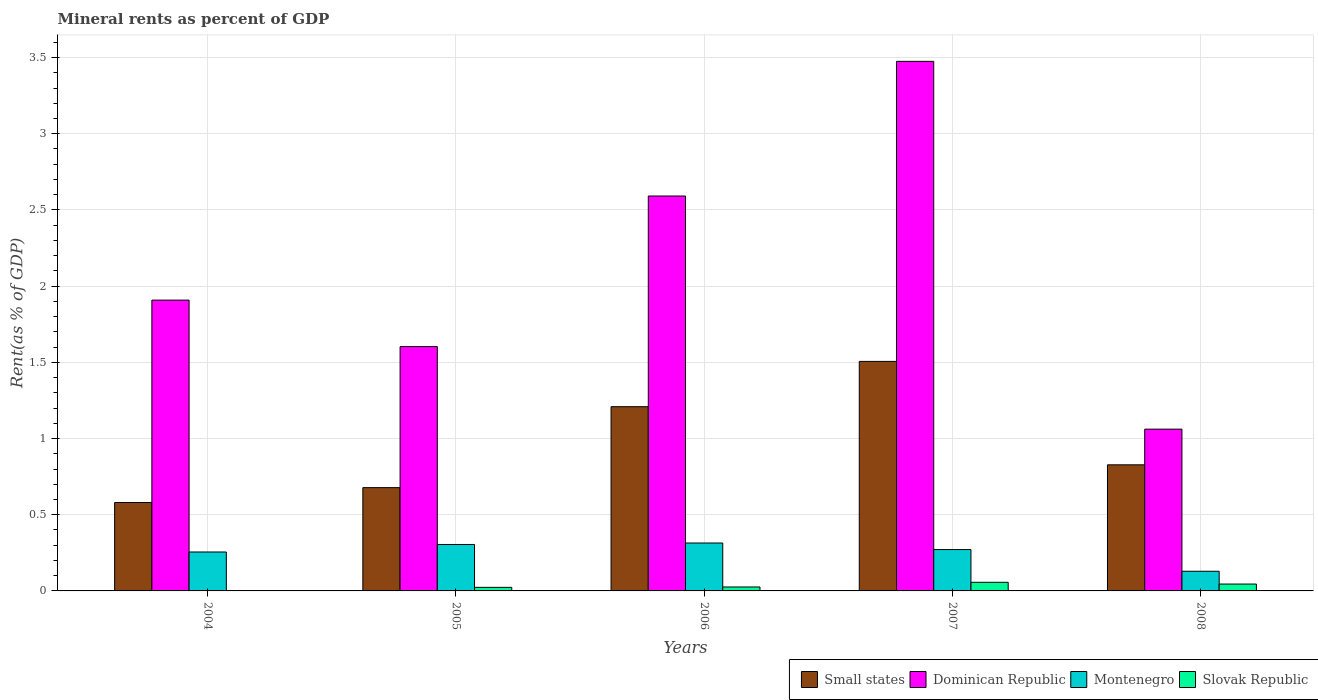How many bars are there on the 3rd tick from the left?
Make the answer very short. 4. What is the label of the 1st group of bars from the left?
Your answer should be very brief. 2004. What is the mineral rent in Montenegro in 2007?
Make the answer very short. 0.27. Across all years, what is the maximum mineral rent in Montenegro?
Ensure brevity in your answer.  0.31. Across all years, what is the minimum mineral rent in Montenegro?
Your response must be concise. 0.13. What is the total mineral rent in Slovak Republic in the graph?
Offer a very short reply. 0.15. What is the difference between the mineral rent in Dominican Republic in 2007 and that in 2008?
Keep it short and to the point. 2.41. What is the difference between the mineral rent in Small states in 2008 and the mineral rent in Montenegro in 2004?
Give a very brief answer. 0.57. What is the average mineral rent in Montenegro per year?
Your response must be concise. 0.26. In the year 2005, what is the difference between the mineral rent in Dominican Republic and mineral rent in Montenegro?
Provide a short and direct response. 1.3. What is the ratio of the mineral rent in Dominican Republic in 2007 to that in 2008?
Offer a very short reply. 3.27. Is the mineral rent in Dominican Republic in 2004 less than that in 2006?
Give a very brief answer. Yes. Is the difference between the mineral rent in Dominican Republic in 2005 and 2006 greater than the difference between the mineral rent in Montenegro in 2005 and 2006?
Your answer should be compact. No. What is the difference between the highest and the second highest mineral rent in Slovak Republic?
Give a very brief answer. 0.01. What is the difference between the highest and the lowest mineral rent in Montenegro?
Keep it short and to the point. 0.19. In how many years, is the mineral rent in Montenegro greater than the average mineral rent in Montenegro taken over all years?
Give a very brief answer. 4. What does the 2nd bar from the left in 2006 represents?
Provide a short and direct response. Dominican Republic. What does the 1st bar from the right in 2007 represents?
Make the answer very short. Slovak Republic. Is it the case that in every year, the sum of the mineral rent in Slovak Republic and mineral rent in Small states is greater than the mineral rent in Dominican Republic?
Offer a terse response. No. How many bars are there?
Offer a terse response. 20. Are all the bars in the graph horizontal?
Your answer should be compact. No. Where does the legend appear in the graph?
Your answer should be very brief. Bottom right. What is the title of the graph?
Ensure brevity in your answer.  Mineral rents as percent of GDP. Does "Turkmenistan" appear as one of the legend labels in the graph?
Make the answer very short. No. What is the label or title of the Y-axis?
Keep it short and to the point. Rent(as % of GDP). What is the Rent(as % of GDP) of Small states in 2004?
Make the answer very short. 0.58. What is the Rent(as % of GDP) of Dominican Republic in 2004?
Make the answer very short. 1.91. What is the Rent(as % of GDP) in Montenegro in 2004?
Keep it short and to the point. 0.26. What is the Rent(as % of GDP) of Slovak Republic in 2004?
Your answer should be very brief. 0. What is the Rent(as % of GDP) in Small states in 2005?
Provide a short and direct response. 0.68. What is the Rent(as % of GDP) in Dominican Republic in 2005?
Give a very brief answer. 1.6. What is the Rent(as % of GDP) in Montenegro in 2005?
Your response must be concise. 0.3. What is the Rent(as % of GDP) of Slovak Republic in 2005?
Ensure brevity in your answer.  0.02. What is the Rent(as % of GDP) in Small states in 2006?
Keep it short and to the point. 1.21. What is the Rent(as % of GDP) in Dominican Republic in 2006?
Your response must be concise. 2.59. What is the Rent(as % of GDP) in Montenegro in 2006?
Provide a succinct answer. 0.31. What is the Rent(as % of GDP) in Slovak Republic in 2006?
Provide a succinct answer. 0.03. What is the Rent(as % of GDP) in Small states in 2007?
Give a very brief answer. 1.51. What is the Rent(as % of GDP) in Dominican Republic in 2007?
Make the answer very short. 3.47. What is the Rent(as % of GDP) in Montenegro in 2007?
Your answer should be very brief. 0.27. What is the Rent(as % of GDP) of Slovak Republic in 2007?
Make the answer very short. 0.06. What is the Rent(as % of GDP) of Small states in 2008?
Keep it short and to the point. 0.83. What is the Rent(as % of GDP) in Dominican Republic in 2008?
Keep it short and to the point. 1.06. What is the Rent(as % of GDP) of Montenegro in 2008?
Provide a short and direct response. 0.13. What is the Rent(as % of GDP) in Slovak Republic in 2008?
Your answer should be very brief. 0.05. Across all years, what is the maximum Rent(as % of GDP) in Small states?
Provide a short and direct response. 1.51. Across all years, what is the maximum Rent(as % of GDP) of Dominican Republic?
Make the answer very short. 3.47. Across all years, what is the maximum Rent(as % of GDP) of Montenegro?
Give a very brief answer. 0.31. Across all years, what is the maximum Rent(as % of GDP) of Slovak Republic?
Your answer should be compact. 0.06. Across all years, what is the minimum Rent(as % of GDP) of Small states?
Your answer should be compact. 0.58. Across all years, what is the minimum Rent(as % of GDP) of Dominican Republic?
Your answer should be very brief. 1.06. Across all years, what is the minimum Rent(as % of GDP) of Montenegro?
Make the answer very short. 0.13. Across all years, what is the minimum Rent(as % of GDP) in Slovak Republic?
Offer a very short reply. 0. What is the total Rent(as % of GDP) in Small states in the graph?
Provide a succinct answer. 4.8. What is the total Rent(as % of GDP) of Dominican Republic in the graph?
Provide a short and direct response. 10.64. What is the total Rent(as % of GDP) in Montenegro in the graph?
Make the answer very short. 1.28. What is the total Rent(as % of GDP) in Slovak Republic in the graph?
Provide a short and direct response. 0.15. What is the difference between the Rent(as % of GDP) in Small states in 2004 and that in 2005?
Offer a terse response. -0.1. What is the difference between the Rent(as % of GDP) in Dominican Republic in 2004 and that in 2005?
Provide a succinct answer. 0.3. What is the difference between the Rent(as % of GDP) in Montenegro in 2004 and that in 2005?
Provide a short and direct response. -0.05. What is the difference between the Rent(as % of GDP) of Slovak Republic in 2004 and that in 2005?
Your response must be concise. -0.02. What is the difference between the Rent(as % of GDP) of Small states in 2004 and that in 2006?
Provide a short and direct response. -0.63. What is the difference between the Rent(as % of GDP) in Dominican Republic in 2004 and that in 2006?
Your response must be concise. -0.68. What is the difference between the Rent(as % of GDP) in Montenegro in 2004 and that in 2006?
Ensure brevity in your answer.  -0.06. What is the difference between the Rent(as % of GDP) in Slovak Republic in 2004 and that in 2006?
Your answer should be compact. -0.02. What is the difference between the Rent(as % of GDP) of Small states in 2004 and that in 2007?
Ensure brevity in your answer.  -0.93. What is the difference between the Rent(as % of GDP) of Dominican Republic in 2004 and that in 2007?
Offer a very short reply. -1.57. What is the difference between the Rent(as % of GDP) in Montenegro in 2004 and that in 2007?
Your response must be concise. -0.02. What is the difference between the Rent(as % of GDP) in Slovak Republic in 2004 and that in 2007?
Offer a terse response. -0.06. What is the difference between the Rent(as % of GDP) of Small states in 2004 and that in 2008?
Your response must be concise. -0.25. What is the difference between the Rent(as % of GDP) of Dominican Republic in 2004 and that in 2008?
Your response must be concise. 0.85. What is the difference between the Rent(as % of GDP) in Montenegro in 2004 and that in 2008?
Ensure brevity in your answer.  0.13. What is the difference between the Rent(as % of GDP) in Slovak Republic in 2004 and that in 2008?
Make the answer very short. -0.04. What is the difference between the Rent(as % of GDP) of Small states in 2005 and that in 2006?
Provide a short and direct response. -0.53. What is the difference between the Rent(as % of GDP) of Dominican Republic in 2005 and that in 2006?
Offer a very short reply. -0.99. What is the difference between the Rent(as % of GDP) in Montenegro in 2005 and that in 2006?
Offer a very short reply. -0.01. What is the difference between the Rent(as % of GDP) in Slovak Republic in 2005 and that in 2006?
Offer a very short reply. -0. What is the difference between the Rent(as % of GDP) in Small states in 2005 and that in 2007?
Your answer should be compact. -0.83. What is the difference between the Rent(as % of GDP) in Dominican Republic in 2005 and that in 2007?
Your response must be concise. -1.87. What is the difference between the Rent(as % of GDP) in Slovak Republic in 2005 and that in 2007?
Your answer should be compact. -0.03. What is the difference between the Rent(as % of GDP) in Small states in 2005 and that in 2008?
Offer a very short reply. -0.15. What is the difference between the Rent(as % of GDP) in Dominican Republic in 2005 and that in 2008?
Offer a terse response. 0.54. What is the difference between the Rent(as % of GDP) of Montenegro in 2005 and that in 2008?
Provide a succinct answer. 0.18. What is the difference between the Rent(as % of GDP) of Slovak Republic in 2005 and that in 2008?
Offer a terse response. -0.02. What is the difference between the Rent(as % of GDP) in Small states in 2006 and that in 2007?
Provide a succinct answer. -0.3. What is the difference between the Rent(as % of GDP) in Dominican Republic in 2006 and that in 2007?
Give a very brief answer. -0.88. What is the difference between the Rent(as % of GDP) of Montenegro in 2006 and that in 2007?
Your answer should be very brief. 0.04. What is the difference between the Rent(as % of GDP) of Slovak Republic in 2006 and that in 2007?
Your response must be concise. -0.03. What is the difference between the Rent(as % of GDP) in Small states in 2006 and that in 2008?
Make the answer very short. 0.38. What is the difference between the Rent(as % of GDP) of Dominican Republic in 2006 and that in 2008?
Ensure brevity in your answer.  1.53. What is the difference between the Rent(as % of GDP) in Montenegro in 2006 and that in 2008?
Offer a terse response. 0.19. What is the difference between the Rent(as % of GDP) of Slovak Republic in 2006 and that in 2008?
Make the answer very short. -0.02. What is the difference between the Rent(as % of GDP) of Small states in 2007 and that in 2008?
Your response must be concise. 0.68. What is the difference between the Rent(as % of GDP) in Dominican Republic in 2007 and that in 2008?
Keep it short and to the point. 2.41. What is the difference between the Rent(as % of GDP) of Montenegro in 2007 and that in 2008?
Give a very brief answer. 0.14. What is the difference between the Rent(as % of GDP) of Slovak Republic in 2007 and that in 2008?
Your response must be concise. 0.01. What is the difference between the Rent(as % of GDP) of Small states in 2004 and the Rent(as % of GDP) of Dominican Republic in 2005?
Offer a terse response. -1.02. What is the difference between the Rent(as % of GDP) of Small states in 2004 and the Rent(as % of GDP) of Montenegro in 2005?
Provide a short and direct response. 0.28. What is the difference between the Rent(as % of GDP) of Small states in 2004 and the Rent(as % of GDP) of Slovak Republic in 2005?
Provide a short and direct response. 0.56. What is the difference between the Rent(as % of GDP) of Dominican Republic in 2004 and the Rent(as % of GDP) of Montenegro in 2005?
Your answer should be compact. 1.6. What is the difference between the Rent(as % of GDP) in Dominican Republic in 2004 and the Rent(as % of GDP) in Slovak Republic in 2005?
Give a very brief answer. 1.88. What is the difference between the Rent(as % of GDP) of Montenegro in 2004 and the Rent(as % of GDP) of Slovak Republic in 2005?
Make the answer very short. 0.23. What is the difference between the Rent(as % of GDP) in Small states in 2004 and the Rent(as % of GDP) in Dominican Republic in 2006?
Provide a succinct answer. -2.01. What is the difference between the Rent(as % of GDP) in Small states in 2004 and the Rent(as % of GDP) in Montenegro in 2006?
Your response must be concise. 0.27. What is the difference between the Rent(as % of GDP) in Small states in 2004 and the Rent(as % of GDP) in Slovak Republic in 2006?
Your response must be concise. 0.55. What is the difference between the Rent(as % of GDP) in Dominican Republic in 2004 and the Rent(as % of GDP) in Montenegro in 2006?
Offer a very short reply. 1.59. What is the difference between the Rent(as % of GDP) of Dominican Republic in 2004 and the Rent(as % of GDP) of Slovak Republic in 2006?
Provide a short and direct response. 1.88. What is the difference between the Rent(as % of GDP) in Montenegro in 2004 and the Rent(as % of GDP) in Slovak Republic in 2006?
Your answer should be very brief. 0.23. What is the difference between the Rent(as % of GDP) in Small states in 2004 and the Rent(as % of GDP) in Dominican Republic in 2007?
Provide a succinct answer. -2.9. What is the difference between the Rent(as % of GDP) of Small states in 2004 and the Rent(as % of GDP) of Montenegro in 2007?
Give a very brief answer. 0.31. What is the difference between the Rent(as % of GDP) in Small states in 2004 and the Rent(as % of GDP) in Slovak Republic in 2007?
Make the answer very short. 0.52. What is the difference between the Rent(as % of GDP) in Dominican Republic in 2004 and the Rent(as % of GDP) in Montenegro in 2007?
Your answer should be compact. 1.64. What is the difference between the Rent(as % of GDP) of Dominican Republic in 2004 and the Rent(as % of GDP) of Slovak Republic in 2007?
Give a very brief answer. 1.85. What is the difference between the Rent(as % of GDP) in Montenegro in 2004 and the Rent(as % of GDP) in Slovak Republic in 2007?
Provide a short and direct response. 0.2. What is the difference between the Rent(as % of GDP) of Small states in 2004 and the Rent(as % of GDP) of Dominican Republic in 2008?
Provide a short and direct response. -0.48. What is the difference between the Rent(as % of GDP) in Small states in 2004 and the Rent(as % of GDP) in Montenegro in 2008?
Offer a very short reply. 0.45. What is the difference between the Rent(as % of GDP) in Small states in 2004 and the Rent(as % of GDP) in Slovak Republic in 2008?
Make the answer very short. 0.53. What is the difference between the Rent(as % of GDP) in Dominican Republic in 2004 and the Rent(as % of GDP) in Montenegro in 2008?
Provide a succinct answer. 1.78. What is the difference between the Rent(as % of GDP) of Dominican Republic in 2004 and the Rent(as % of GDP) of Slovak Republic in 2008?
Provide a short and direct response. 1.86. What is the difference between the Rent(as % of GDP) in Montenegro in 2004 and the Rent(as % of GDP) in Slovak Republic in 2008?
Offer a very short reply. 0.21. What is the difference between the Rent(as % of GDP) of Small states in 2005 and the Rent(as % of GDP) of Dominican Republic in 2006?
Give a very brief answer. -1.91. What is the difference between the Rent(as % of GDP) in Small states in 2005 and the Rent(as % of GDP) in Montenegro in 2006?
Keep it short and to the point. 0.36. What is the difference between the Rent(as % of GDP) in Small states in 2005 and the Rent(as % of GDP) in Slovak Republic in 2006?
Your answer should be very brief. 0.65. What is the difference between the Rent(as % of GDP) in Dominican Republic in 2005 and the Rent(as % of GDP) in Montenegro in 2006?
Make the answer very short. 1.29. What is the difference between the Rent(as % of GDP) of Dominican Republic in 2005 and the Rent(as % of GDP) of Slovak Republic in 2006?
Keep it short and to the point. 1.58. What is the difference between the Rent(as % of GDP) in Montenegro in 2005 and the Rent(as % of GDP) in Slovak Republic in 2006?
Ensure brevity in your answer.  0.28. What is the difference between the Rent(as % of GDP) of Small states in 2005 and the Rent(as % of GDP) of Dominican Republic in 2007?
Keep it short and to the point. -2.8. What is the difference between the Rent(as % of GDP) in Small states in 2005 and the Rent(as % of GDP) in Montenegro in 2007?
Make the answer very short. 0.41. What is the difference between the Rent(as % of GDP) of Small states in 2005 and the Rent(as % of GDP) of Slovak Republic in 2007?
Keep it short and to the point. 0.62. What is the difference between the Rent(as % of GDP) in Dominican Republic in 2005 and the Rent(as % of GDP) in Montenegro in 2007?
Make the answer very short. 1.33. What is the difference between the Rent(as % of GDP) in Dominican Republic in 2005 and the Rent(as % of GDP) in Slovak Republic in 2007?
Ensure brevity in your answer.  1.55. What is the difference between the Rent(as % of GDP) in Montenegro in 2005 and the Rent(as % of GDP) in Slovak Republic in 2007?
Give a very brief answer. 0.25. What is the difference between the Rent(as % of GDP) of Small states in 2005 and the Rent(as % of GDP) of Dominican Republic in 2008?
Ensure brevity in your answer.  -0.38. What is the difference between the Rent(as % of GDP) in Small states in 2005 and the Rent(as % of GDP) in Montenegro in 2008?
Make the answer very short. 0.55. What is the difference between the Rent(as % of GDP) in Small states in 2005 and the Rent(as % of GDP) in Slovak Republic in 2008?
Keep it short and to the point. 0.63. What is the difference between the Rent(as % of GDP) of Dominican Republic in 2005 and the Rent(as % of GDP) of Montenegro in 2008?
Offer a terse response. 1.47. What is the difference between the Rent(as % of GDP) in Dominican Republic in 2005 and the Rent(as % of GDP) in Slovak Republic in 2008?
Keep it short and to the point. 1.56. What is the difference between the Rent(as % of GDP) of Montenegro in 2005 and the Rent(as % of GDP) of Slovak Republic in 2008?
Provide a succinct answer. 0.26. What is the difference between the Rent(as % of GDP) of Small states in 2006 and the Rent(as % of GDP) of Dominican Republic in 2007?
Offer a terse response. -2.27. What is the difference between the Rent(as % of GDP) in Small states in 2006 and the Rent(as % of GDP) in Montenegro in 2007?
Keep it short and to the point. 0.94. What is the difference between the Rent(as % of GDP) in Small states in 2006 and the Rent(as % of GDP) in Slovak Republic in 2007?
Keep it short and to the point. 1.15. What is the difference between the Rent(as % of GDP) in Dominican Republic in 2006 and the Rent(as % of GDP) in Montenegro in 2007?
Provide a succinct answer. 2.32. What is the difference between the Rent(as % of GDP) in Dominican Republic in 2006 and the Rent(as % of GDP) in Slovak Republic in 2007?
Your answer should be compact. 2.53. What is the difference between the Rent(as % of GDP) in Montenegro in 2006 and the Rent(as % of GDP) in Slovak Republic in 2007?
Keep it short and to the point. 0.26. What is the difference between the Rent(as % of GDP) in Small states in 2006 and the Rent(as % of GDP) in Dominican Republic in 2008?
Your response must be concise. 0.15. What is the difference between the Rent(as % of GDP) in Small states in 2006 and the Rent(as % of GDP) in Montenegro in 2008?
Your answer should be very brief. 1.08. What is the difference between the Rent(as % of GDP) of Small states in 2006 and the Rent(as % of GDP) of Slovak Republic in 2008?
Your answer should be very brief. 1.16. What is the difference between the Rent(as % of GDP) in Dominican Republic in 2006 and the Rent(as % of GDP) in Montenegro in 2008?
Provide a succinct answer. 2.46. What is the difference between the Rent(as % of GDP) in Dominican Republic in 2006 and the Rent(as % of GDP) in Slovak Republic in 2008?
Keep it short and to the point. 2.55. What is the difference between the Rent(as % of GDP) of Montenegro in 2006 and the Rent(as % of GDP) of Slovak Republic in 2008?
Provide a succinct answer. 0.27. What is the difference between the Rent(as % of GDP) of Small states in 2007 and the Rent(as % of GDP) of Dominican Republic in 2008?
Provide a short and direct response. 0.44. What is the difference between the Rent(as % of GDP) of Small states in 2007 and the Rent(as % of GDP) of Montenegro in 2008?
Provide a succinct answer. 1.38. What is the difference between the Rent(as % of GDP) in Small states in 2007 and the Rent(as % of GDP) in Slovak Republic in 2008?
Keep it short and to the point. 1.46. What is the difference between the Rent(as % of GDP) in Dominican Republic in 2007 and the Rent(as % of GDP) in Montenegro in 2008?
Offer a terse response. 3.35. What is the difference between the Rent(as % of GDP) of Dominican Republic in 2007 and the Rent(as % of GDP) of Slovak Republic in 2008?
Your answer should be compact. 3.43. What is the difference between the Rent(as % of GDP) in Montenegro in 2007 and the Rent(as % of GDP) in Slovak Republic in 2008?
Your answer should be compact. 0.23. What is the average Rent(as % of GDP) of Small states per year?
Provide a succinct answer. 0.96. What is the average Rent(as % of GDP) of Dominican Republic per year?
Make the answer very short. 2.13. What is the average Rent(as % of GDP) of Montenegro per year?
Offer a terse response. 0.26. What is the average Rent(as % of GDP) of Slovak Republic per year?
Make the answer very short. 0.03. In the year 2004, what is the difference between the Rent(as % of GDP) in Small states and Rent(as % of GDP) in Dominican Republic?
Your answer should be very brief. -1.33. In the year 2004, what is the difference between the Rent(as % of GDP) of Small states and Rent(as % of GDP) of Montenegro?
Offer a terse response. 0.32. In the year 2004, what is the difference between the Rent(as % of GDP) in Small states and Rent(as % of GDP) in Slovak Republic?
Your answer should be compact. 0.58. In the year 2004, what is the difference between the Rent(as % of GDP) of Dominican Republic and Rent(as % of GDP) of Montenegro?
Your response must be concise. 1.65. In the year 2004, what is the difference between the Rent(as % of GDP) in Dominican Republic and Rent(as % of GDP) in Slovak Republic?
Provide a succinct answer. 1.91. In the year 2004, what is the difference between the Rent(as % of GDP) in Montenegro and Rent(as % of GDP) in Slovak Republic?
Offer a very short reply. 0.25. In the year 2005, what is the difference between the Rent(as % of GDP) of Small states and Rent(as % of GDP) of Dominican Republic?
Keep it short and to the point. -0.93. In the year 2005, what is the difference between the Rent(as % of GDP) in Small states and Rent(as % of GDP) in Montenegro?
Make the answer very short. 0.37. In the year 2005, what is the difference between the Rent(as % of GDP) of Small states and Rent(as % of GDP) of Slovak Republic?
Make the answer very short. 0.65. In the year 2005, what is the difference between the Rent(as % of GDP) in Dominican Republic and Rent(as % of GDP) in Montenegro?
Your response must be concise. 1.3. In the year 2005, what is the difference between the Rent(as % of GDP) of Dominican Republic and Rent(as % of GDP) of Slovak Republic?
Offer a terse response. 1.58. In the year 2005, what is the difference between the Rent(as % of GDP) in Montenegro and Rent(as % of GDP) in Slovak Republic?
Offer a very short reply. 0.28. In the year 2006, what is the difference between the Rent(as % of GDP) in Small states and Rent(as % of GDP) in Dominican Republic?
Provide a succinct answer. -1.38. In the year 2006, what is the difference between the Rent(as % of GDP) in Small states and Rent(as % of GDP) in Montenegro?
Your response must be concise. 0.89. In the year 2006, what is the difference between the Rent(as % of GDP) in Small states and Rent(as % of GDP) in Slovak Republic?
Provide a short and direct response. 1.18. In the year 2006, what is the difference between the Rent(as % of GDP) of Dominican Republic and Rent(as % of GDP) of Montenegro?
Offer a very short reply. 2.28. In the year 2006, what is the difference between the Rent(as % of GDP) of Dominican Republic and Rent(as % of GDP) of Slovak Republic?
Keep it short and to the point. 2.57. In the year 2006, what is the difference between the Rent(as % of GDP) in Montenegro and Rent(as % of GDP) in Slovak Republic?
Your answer should be compact. 0.29. In the year 2007, what is the difference between the Rent(as % of GDP) in Small states and Rent(as % of GDP) in Dominican Republic?
Offer a terse response. -1.97. In the year 2007, what is the difference between the Rent(as % of GDP) in Small states and Rent(as % of GDP) in Montenegro?
Your response must be concise. 1.23. In the year 2007, what is the difference between the Rent(as % of GDP) of Small states and Rent(as % of GDP) of Slovak Republic?
Ensure brevity in your answer.  1.45. In the year 2007, what is the difference between the Rent(as % of GDP) of Dominican Republic and Rent(as % of GDP) of Montenegro?
Provide a succinct answer. 3.2. In the year 2007, what is the difference between the Rent(as % of GDP) of Dominican Republic and Rent(as % of GDP) of Slovak Republic?
Your answer should be compact. 3.42. In the year 2007, what is the difference between the Rent(as % of GDP) of Montenegro and Rent(as % of GDP) of Slovak Republic?
Make the answer very short. 0.21. In the year 2008, what is the difference between the Rent(as % of GDP) of Small states and Rent(as % of GDP) of Dominican Republic?
Offer a very short reply. -0.23. In the year 2008, what is the difference between the Rent(as % of GDP) of Small states and Rent(as % of GDP) of Montenegro?
Provide a succinct answer. 0.7. In the year 2008, what is the difference between the Rent(as % of GDP) in Small states and Rent(as % of GDP) in Slovak Republic?
Ensure brevity in your answer.  0.78. In the year 2008, what is the difference between the Rent(as % of GDP) in Dominican Republic and Rent(as % of GDP) in Montenegro?
Offer a terse response. 0.93. In the year 2008, what is the difference between the Rent(as % of GDP) in Dominican Republic and Rent(as % of GDP) in Slovak Republic?
Make the answer very short. 1.02. In the year 2008, what is the difference between the Rent(as % of GDP) of Montenegro and Rent(as % of GDP) of Slovak Republic?
Your answer should be very brief. 0.08. What is the ratio of the Rent(as % of GDP) of Small states in 2004 to that in 2005?
Give a very brief answer. 0.86. What is the ratio of the Rent(as % of GDP) in Dominican Republic in 2004 to that in 2005?
Ensure brevity in your answer.  1.19. What is the ratio of the Rent(as % of GDP) of Montenegro in 2004 to that in 2005?
Offer a terse response. 0.84. What is the ratio of the Rent(as % of GDP) in Slovak Republic in 2004 to that in 2005?
Your answer should be very brief. 0.06. What is the ratio of the Rent(as % of GDP) of Small states in 2004 to that in 2006?
Your response must be concise. 0.48. What is the ratio of the Rent(as % of GDP) of Dominican Republic in 2004 to that in 2006?
Offer a very short reply. 0.74. What is the ratio of the Rent(as % of GDP) of Montenegro in 2004 to that in 2006?
Your answer should be very brief. 0.81. What is the ratio of the Rent(as % of GDP) of Slovak Republic in 2004 to that in 2006?
Offer a very short reply. 0.06. What is the ratio of the Rent(as % of GDP) in Small states in 2004 to that in 2007?
Your answer should be very brief. 0.39. What is the ratio of the Rent(as % of GDP) in Dominican Republic in 2004 to that in 2007?
Your response must be concise. 0.55. What is the ratio of the Rent(as % of GDP) in Montenegro in 2004 to that in 2007?
Provide a short and direct response. 0.94. What is the ratio of the Rent(as % of GDP) in Slovak Republic in 2004 to that in 2007?
Offer a very short reply. 0.03. What is the ratio of the Rent(as % of GDP) in Small states in 2004 to that in 2008?
Your answer should be compact. 0.7. What is the ratio of the Rent(as % of GDP) of Dominican Republic in 2004 to that in 2008?
Make the answer very short. 1.8. What is the ratio of the Rent(as % of GDP) in Montenegro in 2004 to that in 2008?
Ensure brevity in your answer.  1.98. What is the ratio of the Rent(as % of GDP) in Slovak Republic in 2004 to that in 2008?
Ensure brevity in your answer.  0.03. What is the ratio of the Rent(as % of GDP) of Small states in 2005 to that in 2006?
Make the answer very short. 0.56. What is the ratio of the Rent(as % of GDP) of Dominican Republic in 2005 to that in 2006?
Give a very brief answer. 0.62. What is the ratio of the Rent(as % of GDP) in Montenegro in 2005 to that in 2006?
Provide a succinct answer. 0.97. What is the ratio of the Rent(as % of GDP) of Slovak Republic in 2005 to that in 2006?
Ensure brevity in your answer.  0.9. What is the ratio of the Rent(as % of GDP) in Small states in 2005 to that in 2007?
Offer a very short reply. 0.45. What is the ratio of the Rent(as % of GDP) of Dominican Republic in 2005 to that in 2007?
Make the answer very short. 0.46. What is the ratio of the Rent(as % of GDP) in Montenegro in 2005 to that in 2007?
Provide a short and direct response. 1.12. What is the ratio of the Rent(as % of GDP) of Slovak Republic in 2005 to that in 2007?
Offer a terse response. 0.42. What is the ratio of the Rent(as % of GDP) in Small states in 2005 to that in 2008?
Your answer should be compact. 0.82. What is the ratio of the Rent(as % of GDP) of Dominican Republic in 2005 to that in 2008?
Offer a terse response. 1.51. What is the ratio of the Rent(as % of GDP) in Montenegro in 2005 to that in 2008?
Your answer should be compact. 2.36. What is the ratio of the Rent(as % of GDP) of Slovak Republic in 2005 to that in 2008?
Offer a terse response. 0.52. What is the ratio of the Rent(as % of GDP) in Small states in 2006 to that in 2007?
Keep it short and to the point. 0.8. What is the ratio of the Rent(as % of GDP) of Dominican Republic in 2006 to that in 2007?
Offer a very short reply. 0.75. What is the ratio of the Rent(as % of GDP) in Montenegro in 2006 to that in 2007?
Your response must be concise. 1.16. What is the ratio of the Rent(as % of GDP) of Slovak Republic in 2006 to that in 2007?
Offer a very short reply. 0.46. What is the ratio of the Rent(as % of GDP) of Small states in 2006 to that in 2008?
Your answer should be compact. 1.46. What is the ratio of the Rent(as % of GDP) in Dominican Republic in 2006 to that in 2008?
Give a very brief answer. 2.44. What is the ratio of the Rent(as % of GDP) in Montenegro in 2006 to that in 2008?
Your answer should be compact. 2.44. What is the ratio of the Rent(as % of GDP) of Slovak Republic in 2006 to that in 2008?
Ensure brevity in your answer.  0.57. What is the ratio of the Rent(as % of GDP) of Small states in 2007 to that in 2008?
Your answer should be very brief. 1.82. What is the ratio of the Rent(as % of GDP) in Dominican Republic in 2007 to that in 2008?
Your answer should be compact. 3.27. What is the ratio of the Rent(as % of GDP) in Montenegro in 2007 to that in 2008?
Keep it short and to the point. 2.1. What is the ratio of the Rent(as % of GDP) of Slovak Republic in 2007 to that in 2008?
Your response must be concise. 1.25. What is the difference between the highest and the second highest Rent(as % of GDP) of Small states?
Provide a succinct answer. 0.3. What is the difference between the highest and the second highest Rent(as % of GDP) in Dominican Republic?
Offer a terse response. 0.88. What is the difference between the highest and the second highest Rent(as % of GDP) of Montenegro?
Give a very brief answer. 0.01. What is the difference between the highest and the second highest Rent(as % of GDP) of Slovak Republic?
Give a very brief answer. 0.01. What is the difference between the highest and the lowest Rent(as % of GDP) in Small states?
Your answer should be compact. 0.93. What is the difference between the highest and the lowest Rent(as % of GDP) of Dominican Republic?
Keep it short and to the point. 2.41. What is the difference between the highest and the lowest Rent(as % of GDP) in Montenegro?
Ensure brevity in your answer.  0.19. What is the difference between the highest and the lowest Rent(as % of GDP) in Slovak Republic?
Your answer should be very brief. 0.06. 